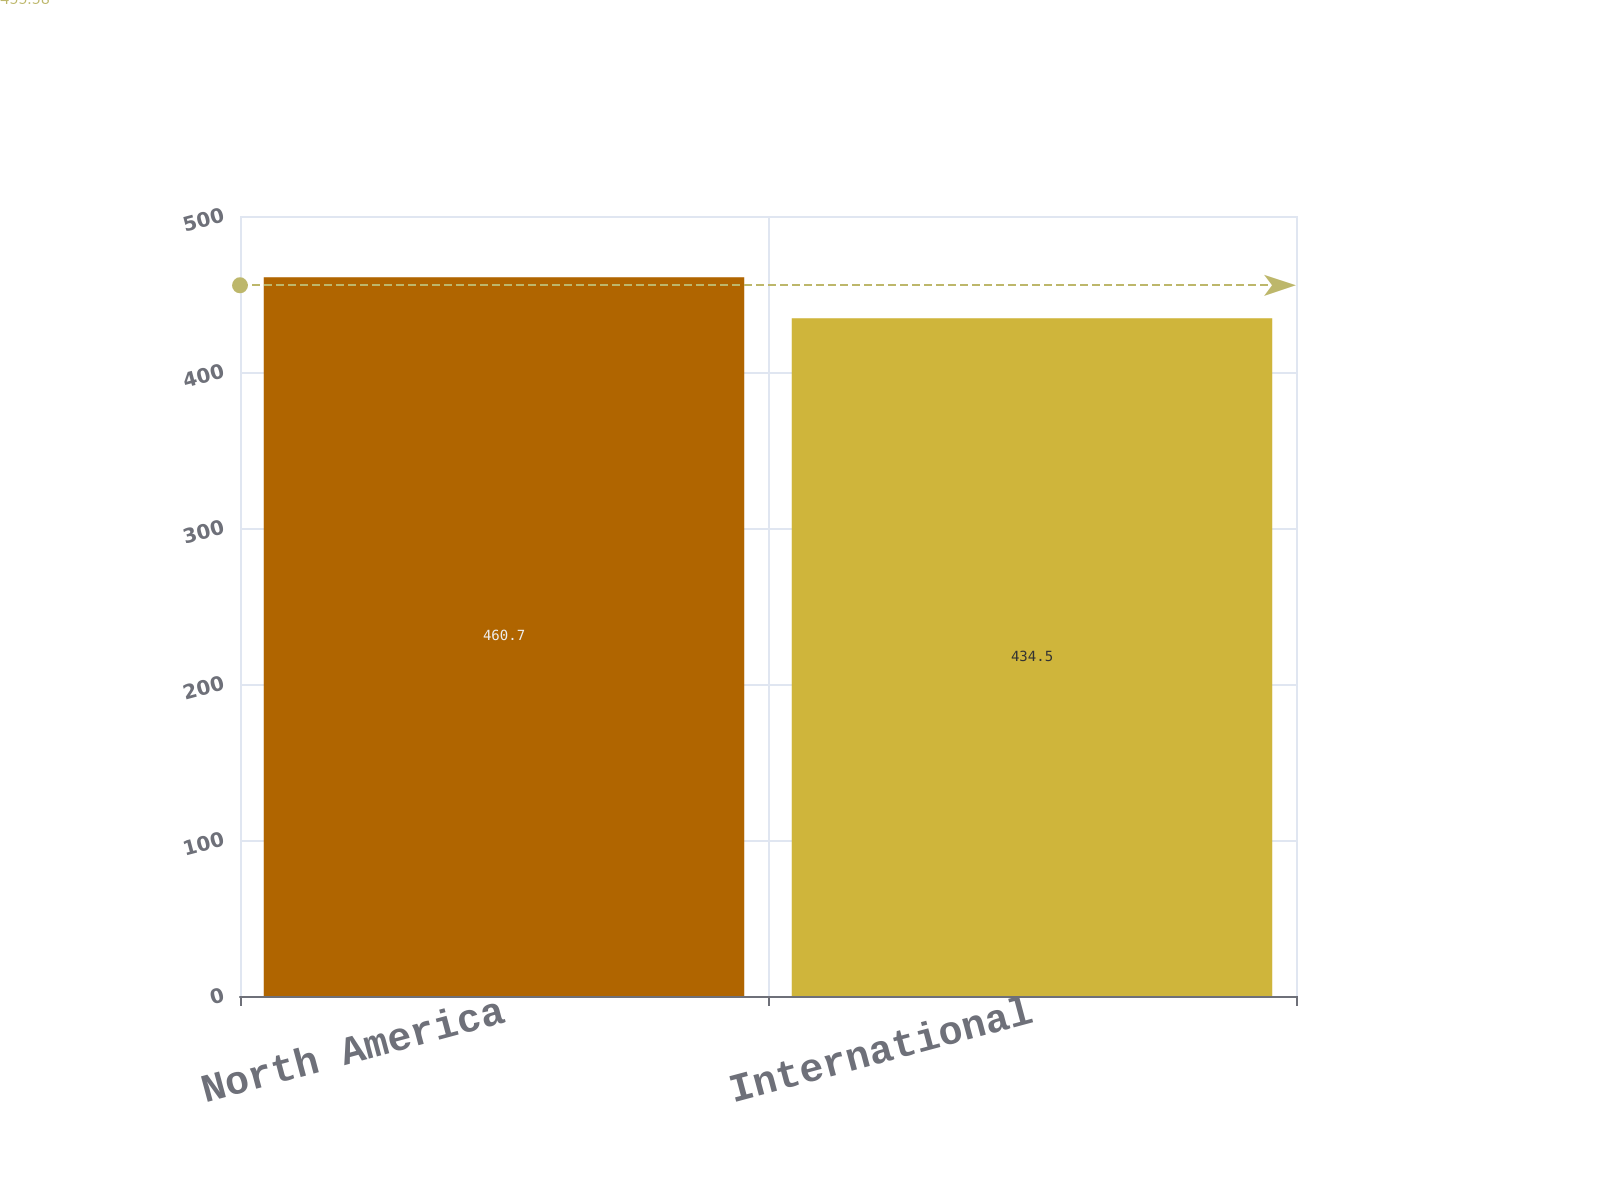Convert chart. <chart><loc_0><loc_0><loc_500><loc_500><bar_chart><fcel>North America<fcel>International<nl><fcel>460.7<fcel>434.5<nl></chart> 